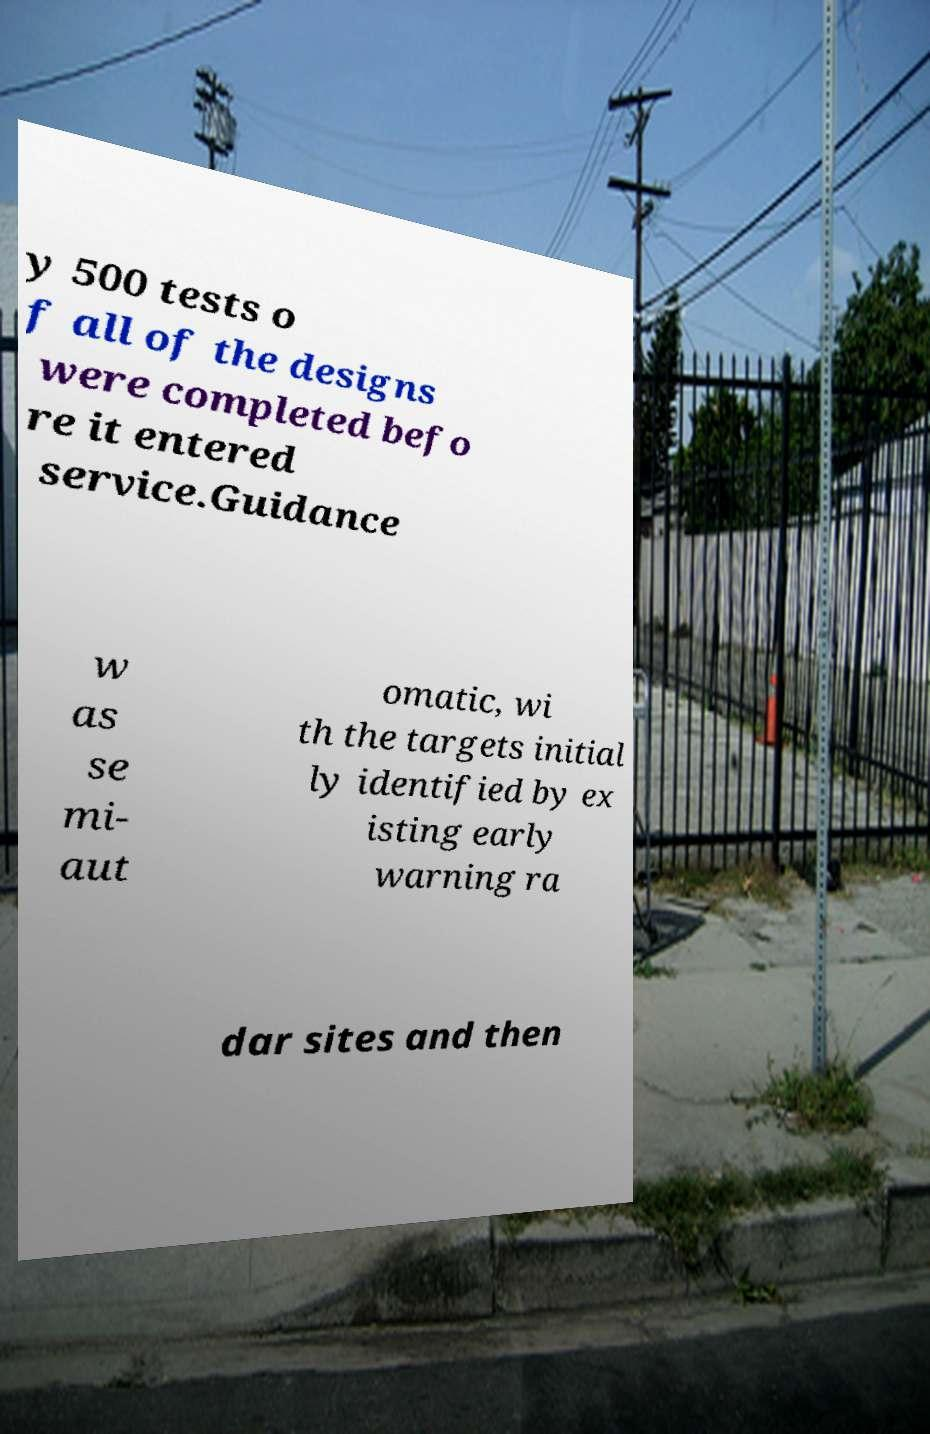Please identify and transcribe the text found in this image. y 500 tests o f all of the designs were completed befo re it entered service.Guidance w as se mi- aut omatic, wi th the targets initial ly identified by ex isting early warning ra dar sites and then 